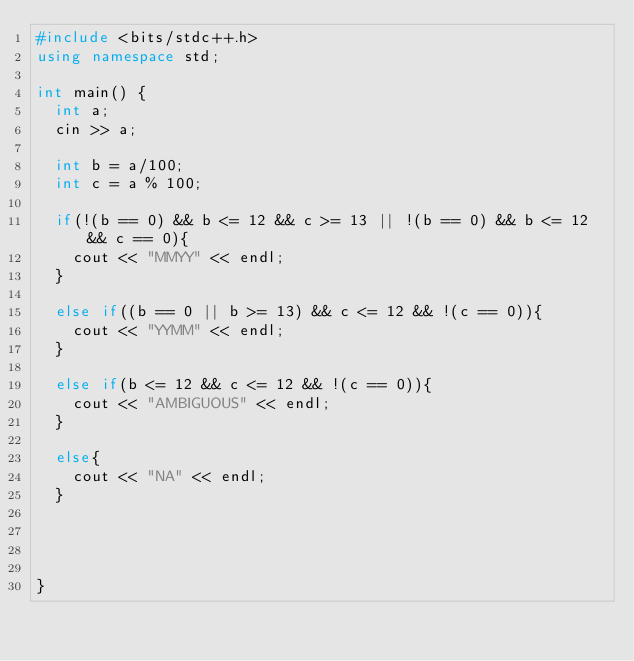Convert code to text. <code><loc_0><loc_0><loc_500><loc_500><_C++_>#include <bits/stdc++.h>
using namespace std;

int main() {
  int a;
  cin >> a;
  
  int b = a/100;
  int c = a % 100;
  
  if(!(b == 0) && b <= 12 && c >= 13 || !(b == 0) && b <= 12 && c == 0){
    cout << "MMYY" << endl;
  }
  
  else if((b == 0 || b >= 13) && c <= 12 && !(c == 0)){
    cout << "YYMM" << endl;
  }
  
  else if(b <= 12 && c <= 12 && !(c == 0)){
    cout << "AMBIGUOUS" << endl;
  }
          
  else{
    cout << "NA" << endl;
  }

  
  
  
}
</code> 